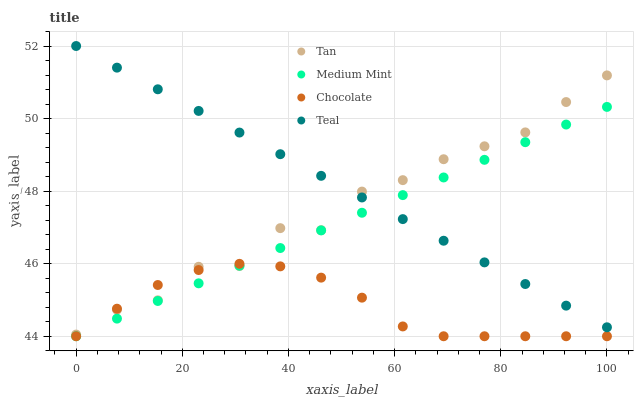Does Chocolate have the minimum area under the curve?
Answer yes or no. Yes. Does Teal have the maximum area under the curve?
Answer yes or no. Yes. Does Tan have the minimum area under the curve?
Answer yes or no. No. Does Tan have the maximum area under the curve?
Answer yes or no. No. Is Medium Mint the smoothest?
Answer yes or no. Yes. Is Tan the roughest?
Answer yes or no. Yes. Is Teal the smoothest?
Answer yes or no. No. Is Teal the roughest?
Answer yes or no. No. Does Medium Mint have the lowest value?
Answer yes or no. Yes. Does Tan have the lowest value?
Answer yes or no. No. Does Teal have the highest value?
Answer yes or no. Yes. Does Tan have the highest value?
Answer yes or no. No. Is Chocolate less than Teal?
Answer yes or no. Yes. Is Teal greater than Chocolate?
Answer yes or no. Yes. Does Medium Mint intersect Chocolate?
Answer yes or no. Yes. Is Medium Mint less than Chocolate?
Answer yes or no. No. Is Medium Mint greater than Chocolate?
Answer yes or no. No. Does Chocolate intersect Teal?
Answer yes or no. No. 